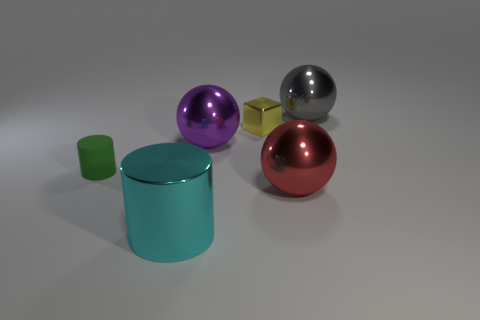The cylinder that is made of the same material as the large purple ball is what color? The cylinder sharing the same material characteristics as the large purple ball has a cyan hue, which is a greenish-blue color. This observation is based on the reflective qualities and the similarity in surface appearance, indicating they are made from the same or a very similar material. 